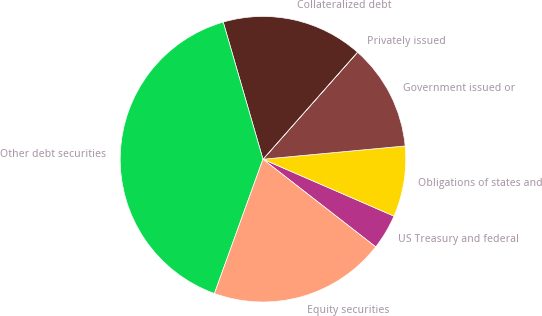Convert chart to OTSL. <chart><loc_0><loc_0><loc_500><loc_500><pie_chart><fcel>US Treasury and federal<fcel>Obligations of states and<fcel>Government issued or<fcel>Privately issued<fcel>Collateralized debt<fcel>Other debt securities<fcel>Equity securities<nl><fcel>4.0%<fcel>8.0%<fcel>12.0%<fcel>0.01%<fcel>16.0%<fcel>39.99%<fcel>20.0%<nl></chart> 